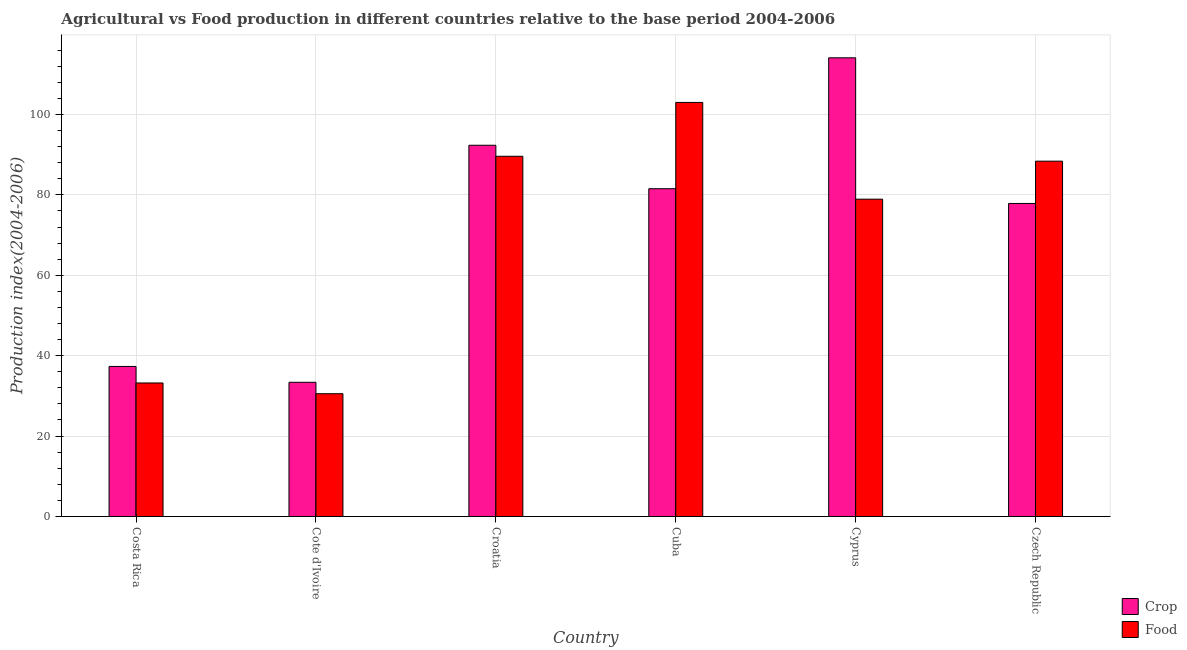How many different coloured bars are there?
Keep it short and to the point. 2. How many groups of bars are there?
Make the answer very short. 6. Are the number of bars per tick equal to the number of legend labels?
Offer a very short reply. Yes. Are the number of bars on each tick of the X-axis equal?
Your answer should be very brief. Yes. What is the label of the 4th group of bars from the left?
Give a very brief answer. Cuba. In how many cases, is the number of bars for a given country not equal to the number of legend labels?
Your answer should be very brief. 0. What is the crop production index in Czech Republic?
Your answer should be very brief. 77.86. Across all countries, what is the maximum food production index?
Your response must be concise. 102.99. Across all countries, what is the minimum food production index?
Offer a terse response. 30.54. In which country was the food production index maximum?
Your answer should be compact. Cuba. In which country was the crop production index minimum?
Offer a very short reply. Cote d'Ivoire. What is the total crop production index in the graph?
Offer a very short reply. 436.52. What is the difference between the food production index in Cote d'Ivoire and that in Czech Republic?
Provide a short and direct response. -57.84. What is the difference between the crop production index in Cote d'Ivoire and the food production index in Czech Republic?
Keep it short and to the point. -55. What is the average food production index per country?
Your response must be concise. 70.61. What is the difference between the crop production index and food production index in Cuba?
Provide a succinct answer. -21.46. In how many countries, is the food production index greater than 80 ?
Offer a very short reply. 3. What is the ratio of the crop production index in Croatia to that in Czech Republic?
Your answer should be very brief. 1.19. What is the difference between the highest and the second highest crop production index?
Give a very brief answer. 21.75. What is the difference between the highest and the lowest crop production index?
Give a very brief answer. 80.71. In how many countries, is the food production index greater than the average food production index taken over all countries?
Your answer should be compact. 4. Is the sum of the food production index in Cuba and Cyprus greater than the maximum crop production index across all countries?
Offer a terse response. Yes. What does the 1st bar from the left in Croatia represents?
Offer a very short reply. Crop. What does the 2nd bar from the right in Czech Republic represents?
Your response must be concise. Crop. Are the values on the major ticks of Y-axis written in scientific E-notation?
Make the answer very short. No. Does the graph contain any zero values?
Make the answer very short. No. What is the title of the graph?
Give a very brief answer. Agricultural vs Food production in different countries relative to the base period 2004-2006. What is the label or title of the X-axis?
Offer a terse response. Country. What is the label or title of the Y-axis?
Offer a terse response. Production index(2004-2006). What is the Production index(2004-2006) in Crop in Costa Rica?
Ensure brevity in your answer.  37.32. What is the Production index(2004-2006) of Food in Costa Rica?
Provide a succinct answer. 33.21. What is the Production index(2004-2006) of Crop in Cote d'Ivoire?
Your response must be concise. 33.38. What is the Production index(2004-2006) of Food in Cote d'Ivoire?
Provide a succinct answer. 30.54. What is the Production index(2004-2006) in Crop in Croatia?
Ensure brevity in your answer.  92.34. What is the Production index(2004-2006) in Food in Croatia?
Ensure brevity in your answer.  89.6. What is the Production index(2004-2006) of Crop in Cuba?
Give a very brief answer. 81.53. What is the Production index(2004-2006) in Food in Cuba?
Provide a short and direct response. 102.99. What is the Production index(2004-2006) of Crop in Cyprus?
Your answer should be compact. 114.09. What is the Production index(2004-2006) in Food in Cyprus?
Give a very brief answer. 78.93. What is the Production index(2004-2006) of Crop in Czech Republic?
Your response must be concise. 77.86. What is the Production index(2004-2006) in Food in Czech Republic?
Give a very brief answer. 88.38. Across all countries, what is the maximum Production index(2004-2006) of Crop?
Your response must be concise. 114.09. Across all countries, what is the maximum Production index(2004-2006) in Food?
Your answer should be compact. 102.99. Across all countries, what is the minimum Production index(2004-2006) in Crop?
Offer a very short reply. 33.38. Across all countries, what is the minimum Production index(2004-2006) in Food?
Your response must be concise. 30.54. What is the total Production index(2004-2006) in Crop in the graph?
Make the answer very short. 436.52. What is the total Production index(2004-2006) in Food in the graph?
Offer a very short reply. 423.65. What is the difference between the Production index(2004-2006) in Crop in Costa Rica and that in Cote d'Ivoire?
Keep it short and to the point. 3.94. What is the difference between the Production index(2004-2006) in Food in Costa Rica and that in Cote d'Ivoire?
Your answer should be compact. 2.67. What is the difference between the Production index(2004-2006) of Crop in Costa Rica and that in Croatia?
Your response must be concise. -55.02. What is the difference between the Production index(2004-2006) in Food in Costa Rica and that in Croatia?
Ensure brevity in your answer.  -56.39. What is the difference between the Production index(2004-2006) in Crop in Costa Rica and that in Cuba?
Your answer should be very brief. -44.21. What is the difference between the Production index(2004-2006) in Food in Costa Rica and that in Cuba?
Your answer should be compact. -69.78. What is the difference between the Production index(2004-2006) of Crop in Costa Rica and that in Cyprus?
Offer a terse response. -76.77. What is the difference between the Production index(2004-2006) of Food in Costa Rica and that in Cyprus?
Your answer should be compact. -45.72. What is the difference between the Production index(2004-2006) in Crop in Costa Rica and that in Czech Republic?
Provide a short and direct response. -40.54. What is the difference between the Production index(2004-2006) of Food in Costa Rica and that in Czech Republic?
Ensure brevity in your answer.  -55.17. What is the difference between the Production index(2004-2006) in Crop in Cote d'Ivoire and that in Croatia?
Provide a succinct answer. -58.96. What is the difference between the Production index(2004-2006) of Food in Cote d'Ivoire and that in Croatia?
Your response must be concise. -59.06. What is the difference between the Production index(2004-2006) of Crop in Cote d'Ivoire and that in Cuba?
Offer a terse response. -48.15. What is the difference between the Production index(2004-2006) of Food in Cote d'Ivoire and that in Cuba?
Your answer should be compact. -72.45. What is the difference between the Production index(2004-2006) in Crop in Cote d'Ivoire and that in Cyprus?
Keep it short and to the point. -80.71. What is the difference between the Production index(2004-2006) in Food in Cote d'Ivoire and that in Cyprus?
Give a very brief answer. -48.39. What is the difference between the Production index(2004-2006) in Crop in Cote d'Ivoire and that in Czech Republic?
Your response must be concise. -44.48. What is the difference between the Production index(2004-2006) in Food in Cote d'Ivoire and that in Czech Republic?
Provide a short and direct response. -57.84. What is the difference between the Production index(2004-2006) of Crop in Croatia and that in Cuba?
Keep it short and to the point. 10.81. What is the difference between the Production index(2004-2006) in Food in Croatia and that in Cuba?
Provide a succinct answer. -13.39. What is the difference between the Production index(2004-2006) of Crop in Croatia and that in Cyprus?
Offer a very short reply. -21.75. What is the difference between the Production index(2004-2006) in Food in Croatia and that in Cyprus?
Provide a short and direct response. 10.67. What is the difference between the Production index(2004-2006) in Crop in Croatia and that in Czech Republic?
Provide a short and direct response. 14.48. What is the difference between the Production index(2004-2006) of Food in Croatia and that in Czech Republic?
Make the answer very short. 1.22. What is the difference between the Production index(2004-2006) of Crop in Cuba and that in Cyprus?
Offer a terse response. -32.56. What is the difference between the Production index(2004-2006) of Food in Cuba and that in Cyprus?
Keep it short and to the point. 24.06. What is the difference between the Production index(2004-2006) of Crop in Cuba and that in Czech Republic?
Provide a succinct answer. 3.67. What is the difference between the Production index(2004-2006) in Food in Cuba and that in Czech Republic?
Offer a very short reply. 14.61. What is the difference between the Production index(2004-2006) of Crop in Cyprus and that in Czech Republic?
Make the answer very short. 36.23. What is the difference between the Production index(2004-2006) in Food in Cyprus and that in Czech Republic?
Keep it short and to the point. -9.45. What is the difference between the Production index(2004-2006) of Crop in Costa Rica and the Production index(2004-2006) of Food in Cote d'Ivoire?
Your response must be concise. 6.78. What is the difference between the Production index(2004-2006) of Crop in Costa Rica and the Production index(2004-2006) of Food in Croatia?
Your response must be concise. -52.28. What is the difference between the Production index(2004-2006) of Crop in Costa Rica and the Production index(2004-2006) of Food in Cuba?
Offer a terse response. -65.67. What is the difference between the Production index(2004-2006) in Crop in Costa Rica and the Production index(2004-2006) in Food in Cyprus?
Provide a succinct answer. -41.61. What is the difference between the Production index(2004-2006) in Crop in Costa Rica and the Production index(2004-2006) in Food in Czech Republic?
Your answer should be very brief. -51.06. What is the difference between the Production index(2004-2006) of Crop in Cote d'Ivoire and the Production index(2004-2006) of Food in Croatia?
Offer a very short reply. -56.22. What is the difference between the Production index(2004-2006) of Crop in Cote d'Ivoire and the Production index(2004-2006) of Food in Cuba?
Give a very brief answer. -69.61. What is the difference between the Production index(2004-2006) in Crop in Cote d'Ivoire and the Production index(2004-2006) in Food in Cyprus?
Offer a very short reply. -45.55. What is the difference between the Production index(2004-2006) of Crop in Cote d'Ivoire and the Production index(2004-2006) of Food in Czech Republic?
Provide a succinct answer. -55. What is the difference between the Production index(2004-2006) in Crop in Croatia and the Production index(2004-2006) in Food in Cuba?
Give a very brief answer. -10.65. What is the difference between the Production index(2004-2006) of Crop in Croatia and the Production index(2004-2006) of Food in Cyprus?
Give a very brief answer. 13.41. What is the difference between the Production index(2004-2006) in Crop in Croatia and the Production index(2004-2006) in Food in Czech Republic?
Your answer should be very brief. 3.96. What is the difference between the Production index(2004-2006) of Crop in Cuba and the Production index(2004-2006) of Food in Czech Republic?
Provide a succinct answer. -6.85. What is the difference between the Production index(2004-2006) of Crop in Cyprus and the Production index(2004-2006) of Food in Czech Republic?
Offer a terse response. 25.71. What is the average Production index(2004-2006) in Crop per country?
Ensure brevity in your answer.  72.75. What is the average Production index(2004-2006) in Food per country?
Offer a very short reply. 70.61. What is the difference between the Production index(2004-2006) in Crop and Production index(2004-2006) in Food in Costa Rica?
Give a very brief answer. 4.11. What is the difference between the Production index(2004-2006) of Crop and Production index(2004-2006) of Food in Cote d'Ivoire?
Ensure brevity in your answer.  2.84. What is the difference between the Production index(2004-2006) of Crop and Production index(2004-2006) of Food in Croatia?
Offer a terse response. 2.74. What is the difference between the Production index(2004-2006) of Crop and Production index(2004-2006) of Food in Cuba?
Provide a succinct answer. -21.46. What is the difference between the Production index(2004-2006) in Crop and Production index(2004-2006) in Food in Cyprus?
Offer a very short reply. 35.16. What is the difference between the Production index(2004-2006) of Crop and Production index(2004-2006) of Food in Czech Republic?
Offer a terse response. -10.52. What is the ratio of the Production index(2004-2006) in Crop in Costa Rica to that in Cote d'Ivoire?
Give a very brief answer. 1.12. What is the ratio of the Production index(2004-2006) in Food in Costa Rica to that in Cote d'Ivoire?
Keep it short and to the point. 1.09. What is the ratio of the Production index(2004-2006) of Crop in Costa Rica to that in Croatia?
Provide a succinct answer. 0.4. What is the ratio of the Production index(2004-2006) of Food in Costa Rica to that in Croatia?
Offer a very short reply. 0.37. What is the ratio of the Production index(2004-2006) of Crop in Costa Rica to that in Cuba?
Offer a very short reply. 0.46. What is the ratio of the Production index(2004-2006) of Food in Costa Rica to that in Cuba?
Your answer should be compact. 0.32. What is the ratio of the Production index(2004-2006) in Crop in Costa Rica to that in Cyprus?
Provide a short and direct response. 0.33. What is the ratio of the Production index(2004-2006) in Food in Costa Rica to that in Cyprus?
Provide a succinct answer. 0.42. What is the ratio of the Production index(2004-2006) of Crop in Costa Rica to that in Czech Republic?
Ensure brevity in your answer.  0.48. What is the ratio of the Production index(2004-2006) of Food in Costa Rica to that in Czech Republic?
Give a very brief answer. 0.38. What is the ratio of the Production index(2004-2006) of Crop in Cote d'Ivoire to that in Croatia?
Provide a succinct answer. 0.36. What is the ratio of the Production index(2004-2006) in Food in Cote d'Ivoire to that in Croatia?
Make the answer very short. 0.34. What is the ratio of the Production index(2004-2006) of Crop in Cote d'Ivoire to that in Cuba?
Keep it short and to the point. 0.41. What is the ratio of the Production index(2004-2006) of Food in Cote d'Ivoire to that in Cuba?
Your answer should be compact. 0.3. What is the ratio of the Production index(2004-2006) of Crop in Cote d'Ivoire to that in Cyprus?
Your answer should be very brief. 0.29. What is the ratio of the Production index(2004-2006) of Food in Cote d'Ivoire to that in Cyprus?
Your answer should be very brief. 0.39. What is the ratio of the Production index(2004-2006) in Crop in Cote d'Ivoire to that in Czech Republic?
Give a very brief answer. 0.43. What is the ratio of the Production index(2004-2006) in Food in Cote d'Ivoire to that in Czech Republic?
Keep it short and to the point. 0.35. What is the ratio of the Production index(2004-2006) of Crop in Croatia to that in Cuba?
Your answer should be very brief. 1.13. What is the ratio of the Production index(2004-2006) in Food in Croatia to that in Cuba?
Offer a terse response. 0.87. What is the ratio of the Production index(2004-2006) in Crop in Croatia to that in Cyprus?
Offer a very short reply. 0.81. What is the ratio of the Production index(2004-2006) of Food in Croatia to that in Cyprus?
Your response must be concise. 1.14. What is the ratio of the Production index(2004-2006) of Crop in Croatia to that in Czech Republic?
Provide a succinct answer. 1.19. What is the ratio of the Production index(2004-2006) of Food in Croatia to that in Czech Republic?
Provide a short and direct response. 1.01. What is the ratio of the Production index(2004-2006) of Crop in Cuba to that in Cyprus?
Give a very brief answer. 0.71. What is the ratio of the Production index(2004-2006) in Food in Cuba to that in Cyprus?
Offer a very short reply. 1.3. What is the ratio of the Production index(2004-2006) of Crop in Cuba to that in Czech Republic?
Your answer should be very brief. 1.05. What is the ratio of the Production index(2004-2006) of Food in Cuba to that in Czech Republic?
Your answer should be very brief. 1.17. What is the ratio of the Production index(2004-2006) of Crop in Cyprus to that in Czech Republic?
Your answer should be very brief. 1.47. What is the ratio of the Production index(2004-2006) of Food in Cyprus to that in Czech Republic?
Keep it short and to the point. 0.89. What is the difference between the highest and the second highest Production index(2004-2006) in Crop?
Ensure brevity in your answer.  21.75. What is the difference between the highest and the second highest Production index(2004-2006) of Food?
Ensure brevity in your answer.  13.39. What is the difference between the highest and the lowest Production index(2004-2006) in Crop?
Keep it short and to the point. 80.71. What is the difference between the highest and the lowest Production index(2004-2006) in Food?
Provide a succinct answer. 72.45. 